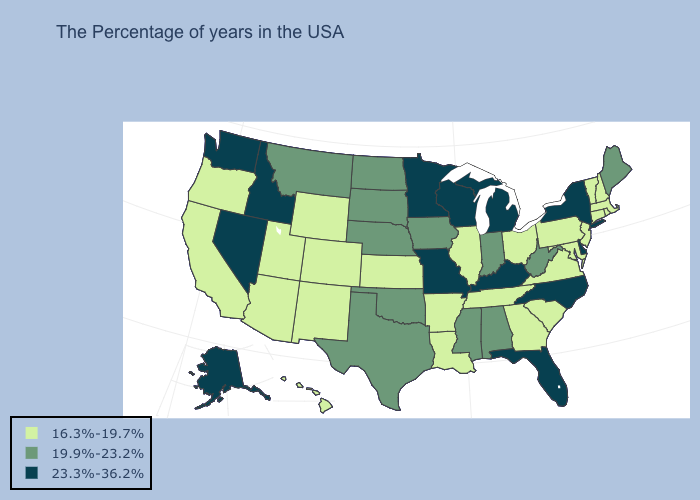Does the map have missing data?
Give a very brief answer. No. What is the value of Texas?
Short answer required. 19.9%-23.2%. How many symbols are there in the legend?
Quick response, please. 3. Does Illinois have the highest value in the USA?
Keep it brief. No. What is the lowest value in the USA?
Be succinct. 16.3%-19.7%. Name the states that have a value in the range 16.3%-19.7%?
Give a very brief answer. Massachusetts, Rhode Island, New Hampshire, Vermont, Connecticut, New Jersey, Maryland, Pennsylvania, Virginia, South Carolina, Ohio, Georgia, Tennessee, Illinois, Louisiana, Arkansas, Kansas, Wyoming, Colorado, New Mexico, Utah, Arizona, California, Oregon, Hawaii. How many symbols are there in the legend?
Answer briefly. 3. Among the states that border North Carolina , which have the highest value?
Answer briefly. Virginia, South Carolina, Georgia, Tennessee. What is the value of Pennsylvania?
Concise answer only. 16.3%-19.7%. Name the states that have a value in the range 16.3%-19.7%?
Write a very short answer. Massachusetts, Rhode Island, New Hampshire, Vermont, Connecticut, New Jersey, Maryland, Pennsylvania, Virginia, South Carolina, Ohio, Georgia, Tennessee, Illinois, Louisiana, Arkansas, Kansas, Wyoming, Colorado, New Mexico, Utah, Arizona, California, Oregon, Hawaii. What is the value of Connecticut?
Give a very brief answer. 16.3%-19.7%. Does Delaware have a higher value than Nevada?
Concise answer only. No. Which states hav the highest value in the MidWest?
Write a very short answer. Michigan, Wisconsin, Missouri, Minnesota. Name the states that have a value in the range 16.3%-19.7%?
Short answer required. Massachusetts, Rhode Island, New Hampshire, Vermont, Connecticut, New Jersey, Maryland, Pennsylvania, Virginia, South Carolina, Ohio, Georgia, Tennessee, Illinois, Louisiana, Arkansas, Kansas, Wyoming, Colorado, New Mexico, Utah, Arizona, California, Oregon, Hawaii. Which states have the lowest value in the MidWest?
Give a very brief answer. Ohio, Illinois, Kansas. 